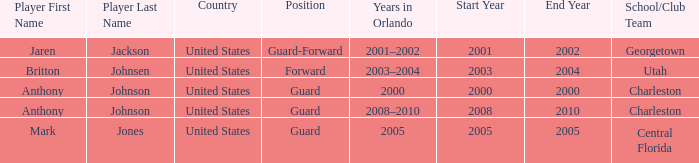Who was the Player that had the Position, guard-forward? Jaren Jackson. 